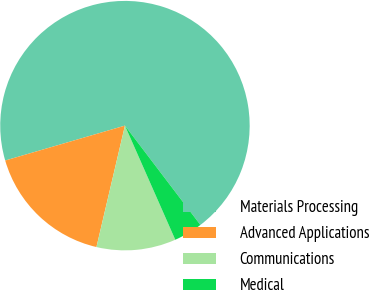Convert chart to OTSL. <chart><loc_0><loc_0><loc_500><loc_500><pie_chart><fcel>Materials Processing<fcel>Advanced Applications<fcel>Communications<fcel>Medical<nl><fcel>69.17%<fcel>16.82%<fcel>10.28%<fcel>3.73%<nl></chart> 